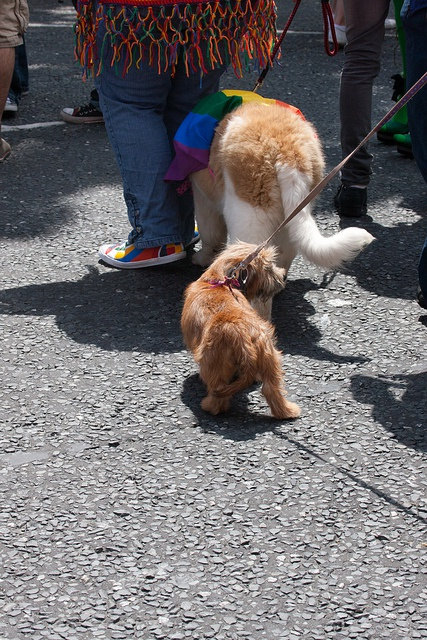Describe the objects in this image and their specific colors. I can see people in black, navy, maroon, and brown tones, dog in black, darkgray, gray, maroon, and lightgray tones, dog in black, maroon, gray, and tan tones, people in black, gray, and darkblue tones, and people in black, gray, and maroon tones in this image. 